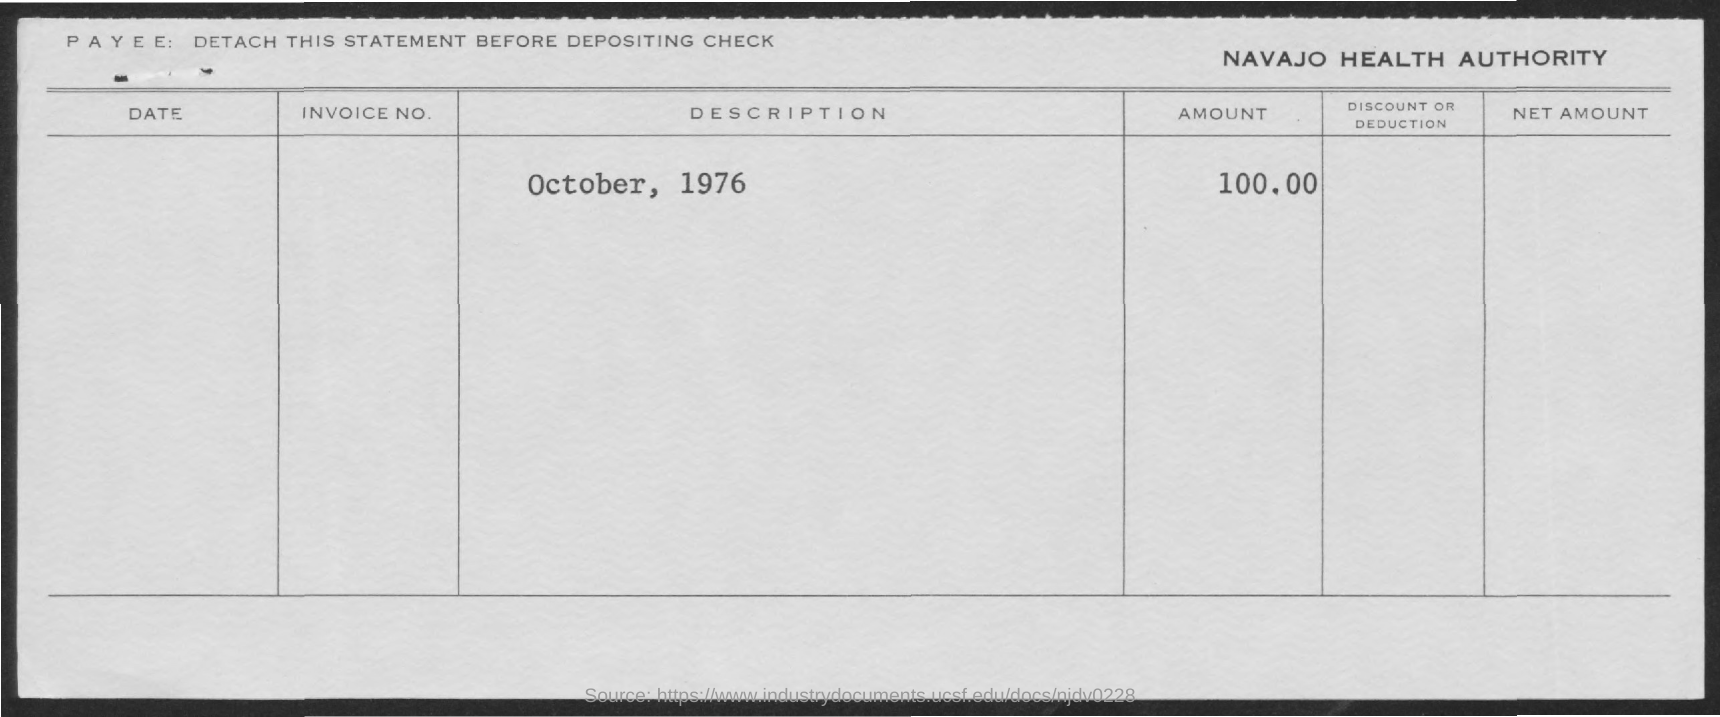What is the name of the authority?
Offer a terse response. Navajo Health Authority. What is the date mentioned?
Keep it short and to the point. OCTOBER, 1976. What is the amount?
Offer a terse response. 100.00. 